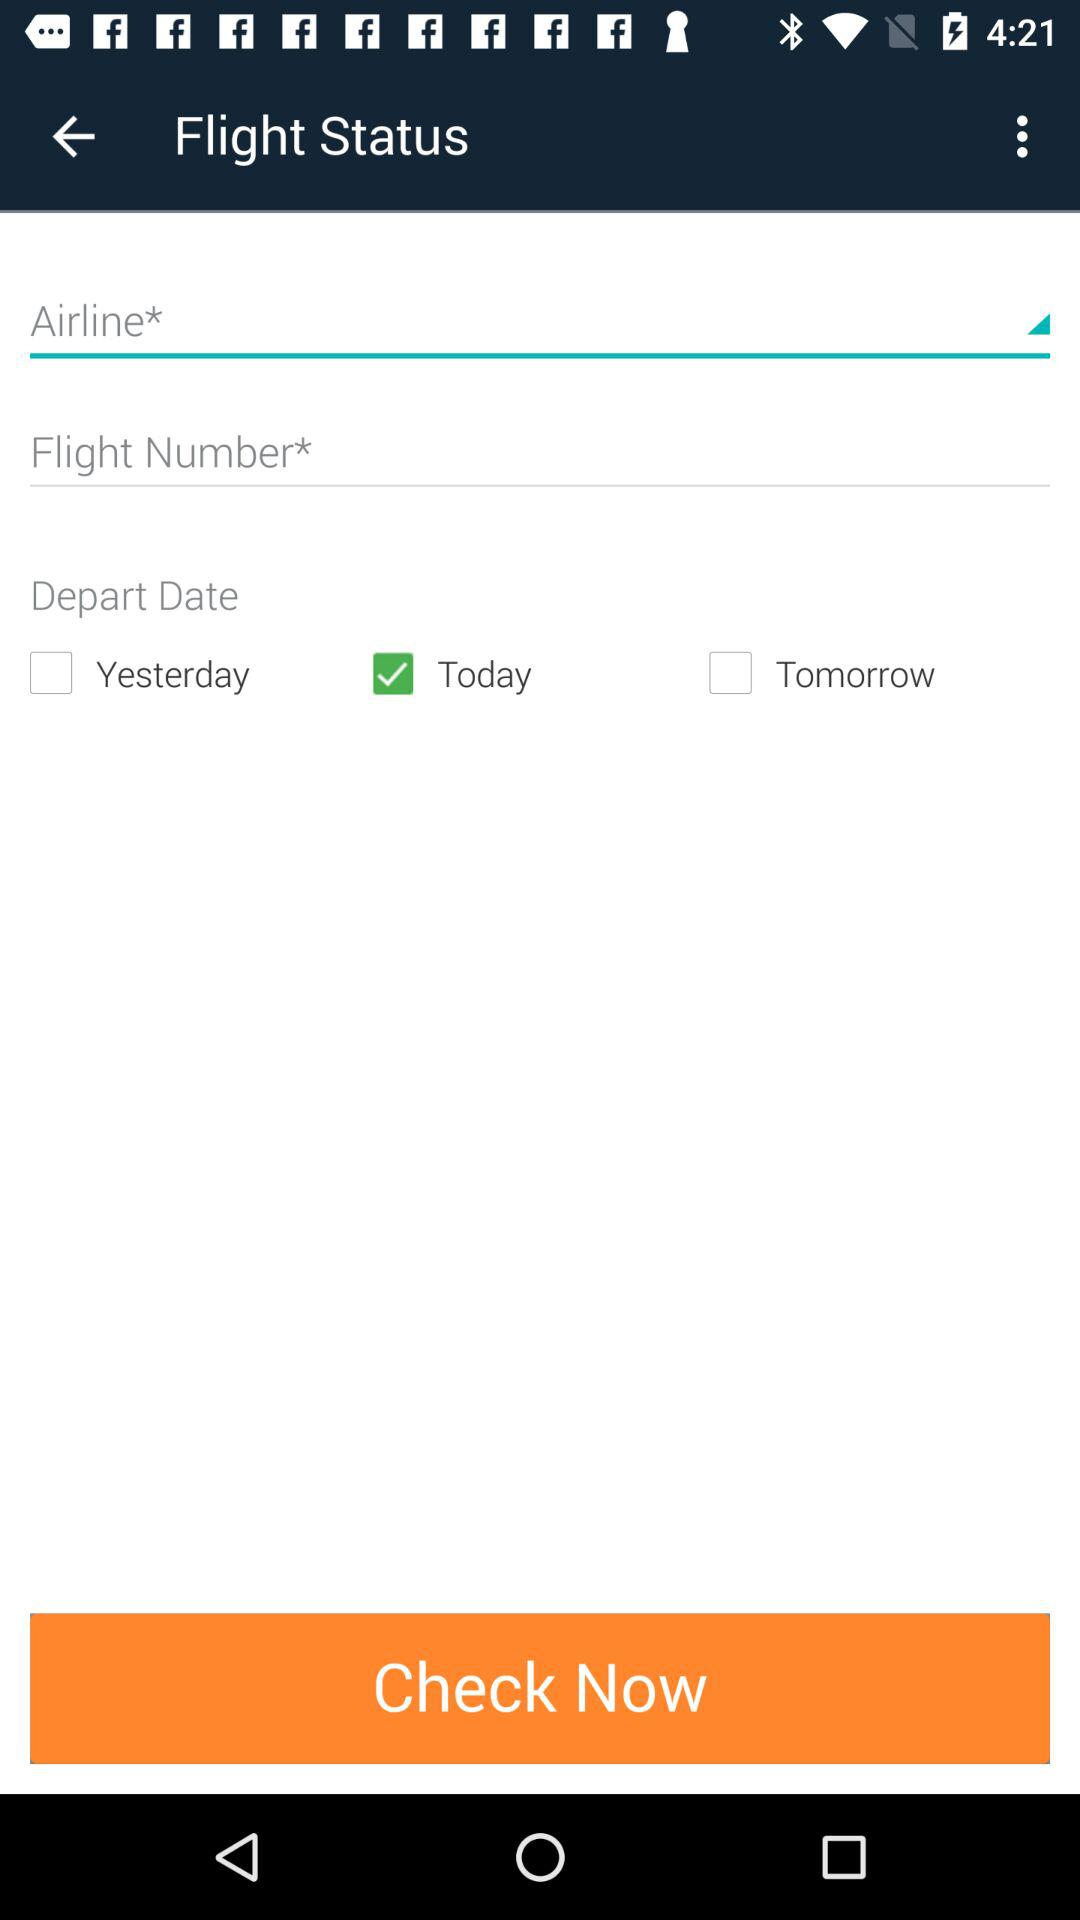How many people are flying?
When the provided information is insufficient, respond with <no answer>. <no answer> 